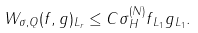<formula> <loc_0><loc_0><loc_500><loc_500>\| W _ { \sigma , Q } ( f , g ) \| _ { L _ { r } } \leq C \| \sigma \| _ { H } ^ { ( N ) } \| f \| _ { L _ { 1 } } \| g \| _ { L _ { 1 } } .</formula> 